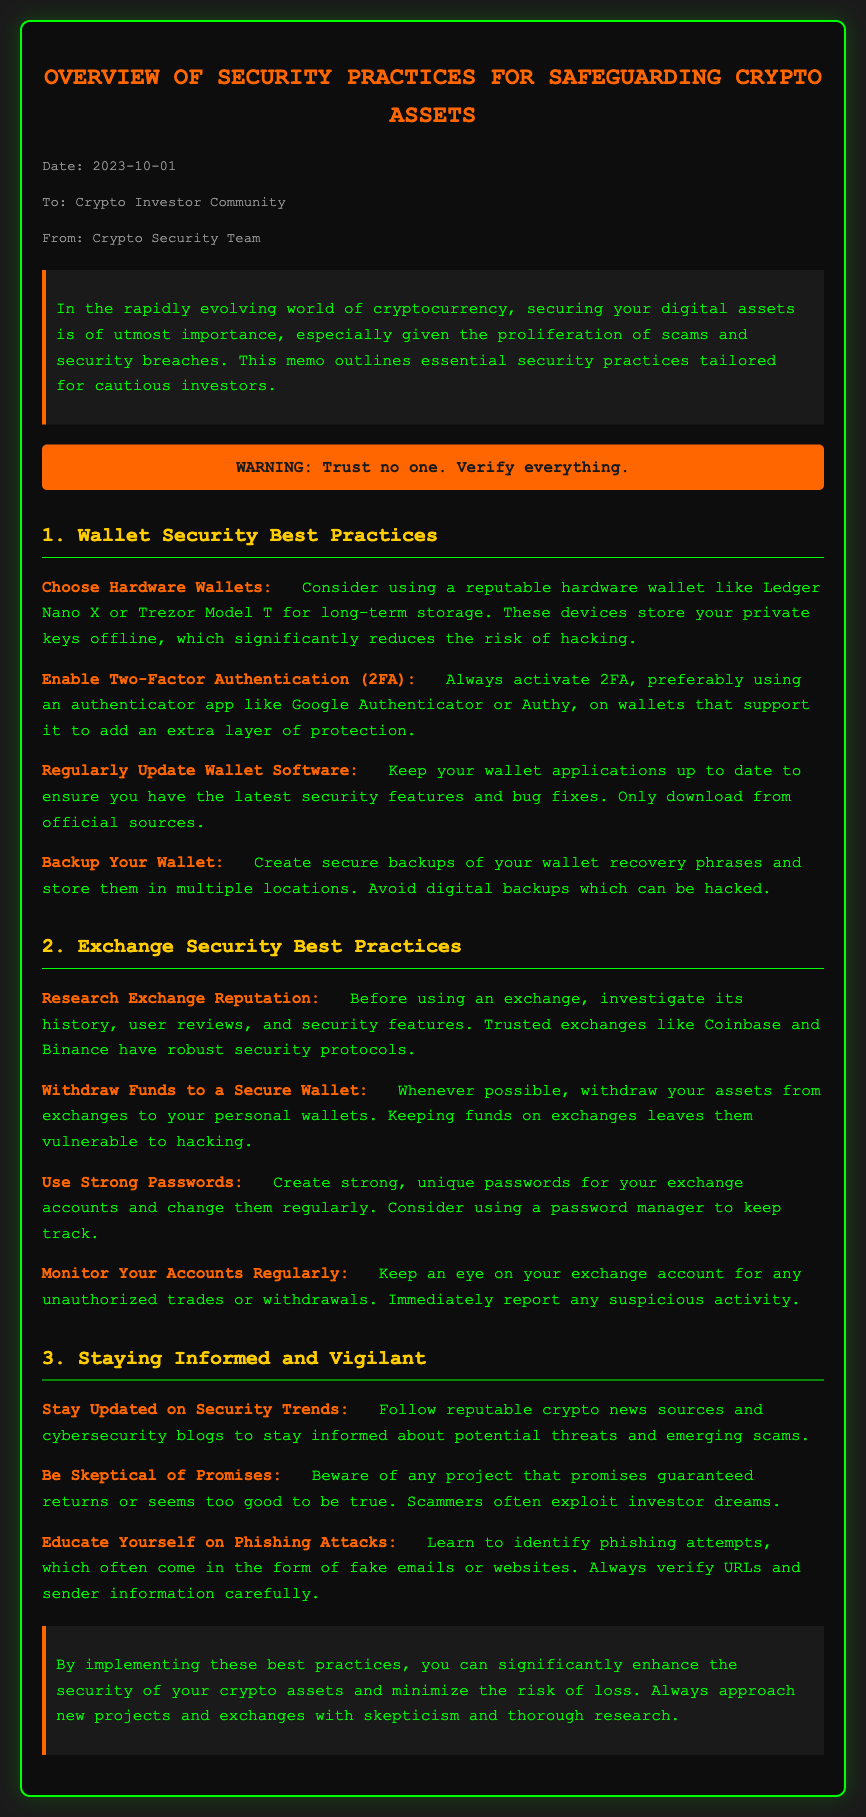What is the date of the memo? The memo includes a date in the meta section, which is October 1, 2023.
Answer: October 1, 2023 Who is the memo addressed to? The meta section specifies the recipient of the memo which is the Crypto Investor Community.
Answer: Crypto Investor Community What does the warning at the top of the document state? The warning emphasizes the importance of trust and verification in crypto security, specifically stating "Trust no one. Verify everything."
Answer: Trust no one. Verify everything Which wallets are recommended for long-term storage? The memo suggests using specific hardware wallets in the wallet security best practices section, naming Ledger Nano X and Trezor Model T.
Answer: Ledger Nano X or Trezor Model T What email app is suggested for enabling two-factor authentication? The details for enabling 2FA in the wallet security best practices section recommend using Google Authenticator or Authy.
Answer: Google Authenticator or Authy Which exchange is mentioned as a trusted option in the memo? The exchange security best practices section lists Coinbase as a trusted exchange.
Answer: Coinbase What should be done with assets that are kept on exchanges? The exchange security practices advise withdrawing assets to personal wallets whenever possible.
Answer: Withdraw your assets to a secure wallet What is a critical action to take regarding account monitoring on exchanges? The document specifies the importance of monitoring accounts for unauthorized trades or withdrawals.
Answer: Monitor Your Accounts Regularly What should investors be cautious about according to the memo? The memo warns investors to be skeptical of projects that promise guaranteed returns.
Answer: Skeptical of promises 